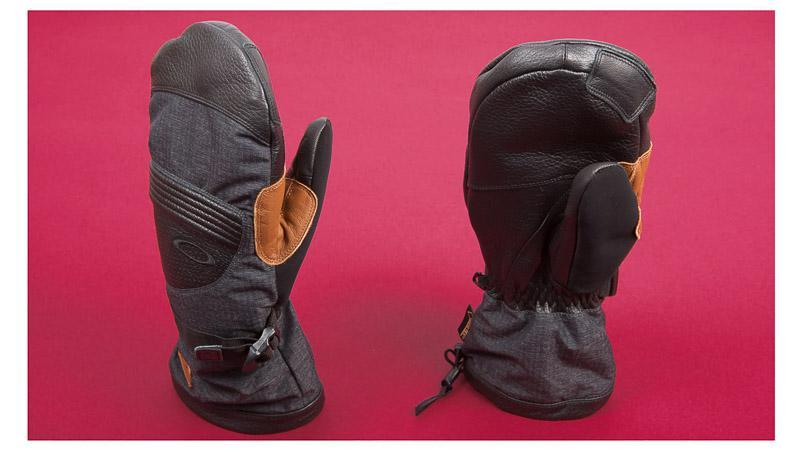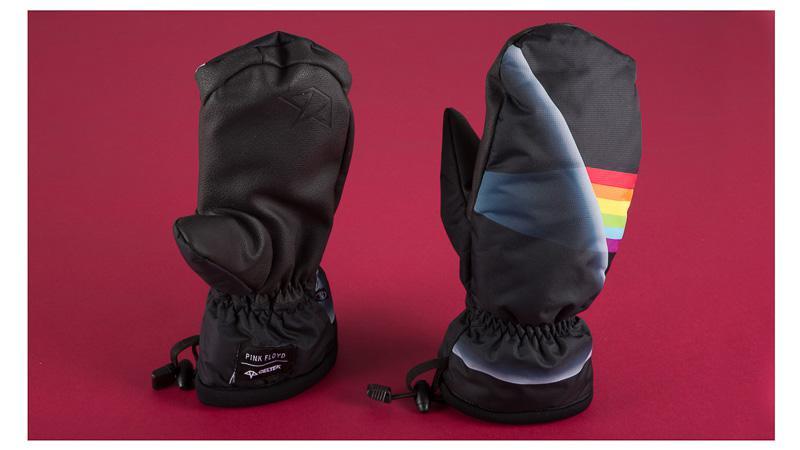The first image is the image on the left, the second image is the image on the right. For the images displayed, is the sentence "The pair of gloves on the right is at least mostly red in color." factually correct? Answer yes or no. No. The first image is the image on the left, the second image is the image on the right. Given the left and right images, does the statement "Images each show one pair of mittens, and the mitten pairs are the same length." hold true? Answer yes or no. Yes. 